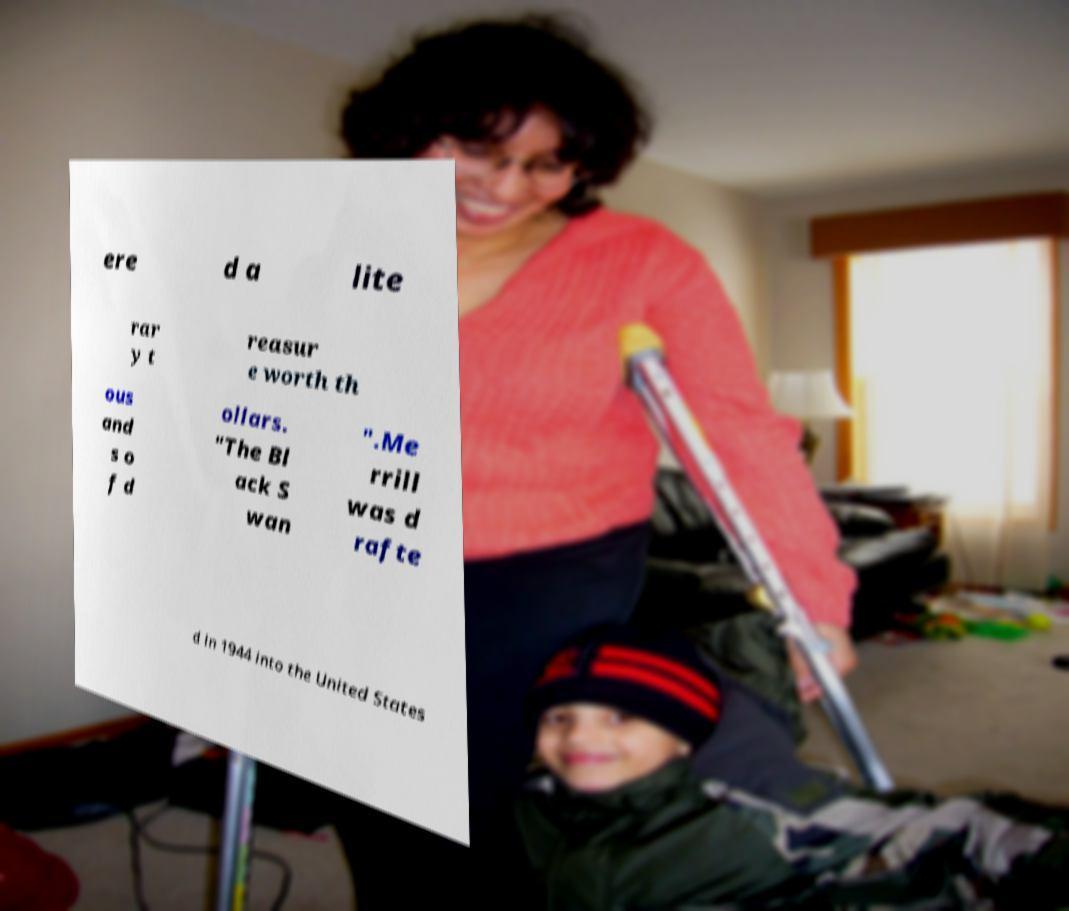Can you read and provide the text displayed in the image?This photo seems to have some interesting text. Can you extract and type it out for me? ere d a lite rar y t reasur e worth th ous and s o f d ollars. "The Bl ack S wan ".Me rrill was d rafte d in 1944 into the United States 